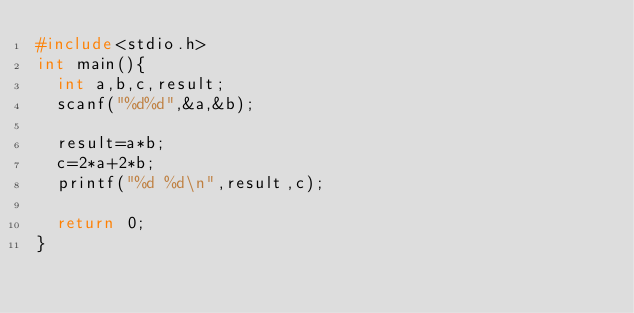<code> <loc_0><loc_0><loc_500><loc_500><_C_>#include<stdio.h>
int main(){
  int a,b,c,result;
  scanf("%d%d",&a,&b);
 
  result=a*b;
  c=2*a+2*b;
  printf("%d %d\n",result,c);
 
  return 0;
}</code> 